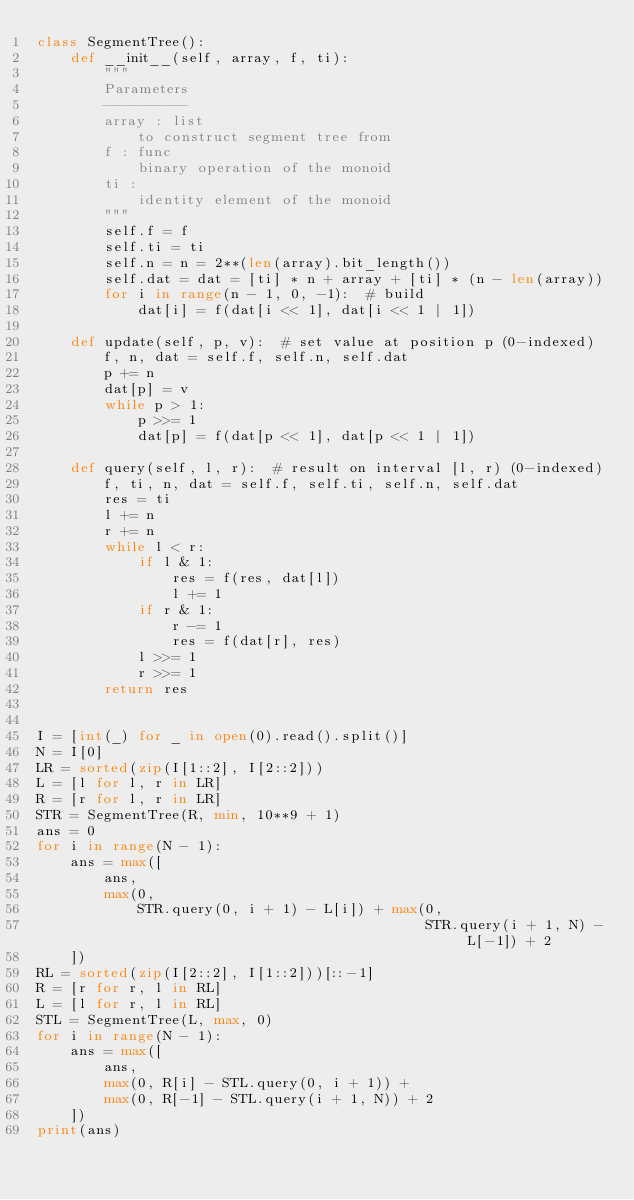Convert code to text. <code><loc_0><loc_0><loc_500><loc_500><_Python_>class SegmentTree():
    def __init__(self, array, f, ti):
        """
        Parameters
        ----------
        array : list
            to construct segment tree from
        f : func
            binary operation of the monoid
        ti : 
            identity element of the monoid
        """
        self.f = f
        self.ti = ti
        self.n = n = 2**(len(array).bit_length())
        self.dat = dat = [ti] * n + array + [ti] * (n - len(array))
        for i in range(n - 1, 0, -1):  # build
            dat[i] = f(dat[i << 1], dat[i << 1 | 1])

    def update(self, p, v):  # set value at position p (0-indexed)
        f, n, dat = self.f, self.n, self.dat
        p += n
        dat[p] = v
        while p > 1:
            p >>= 1
            dat[p] = f(dat[p << 1], dat[p << 1 | 1])

    def query(self, l, r):  # result on interval [l, r) (0-indexed)
        f, ti, n, dat = self.f, self.ti, self.n, self.dat
        res = ti
        l += n
        r += n
        while l < r:
            if l & 1:
                res = f(res, dat[l])
                l += 1
            if r & 1:
                r -= 1
                res = f(dat[r], res)
            l >>= 1
            r >>= 1
        return res


I = [int(_) for _ in open(0).read().split()]
N = I[0]
LR = sorted(zip(I[1::2], I[2::2]))
L = [l for l, r in LR]
R = [r for l, r in LR]
STR = SegmentTree(R, min, 10**9 + 1)
ans = 0
for i in range(N - 1):
    ans = max([
        ans,
        max(0,
            STR.query(0, i + 1) - L[i]) + max(0,
                                              STR.query(i + 1, N) - L[-1]) + 2
    ])
RL = sorted(zip(I[2::2], I[1::2]))[::-1]
R = [r for r, l in RL]
L = [l for r, l in RL]
STL = SegmentTree(L, max, 0)
for i in range(N - 1):
    ans = max([
        ans,
        max(0, R[i] - STL.query(0, i + 1)) +
        max(0, R[-1] - STL.query(i + 1, N)) + 2
    ])
print(ans)
</code> 